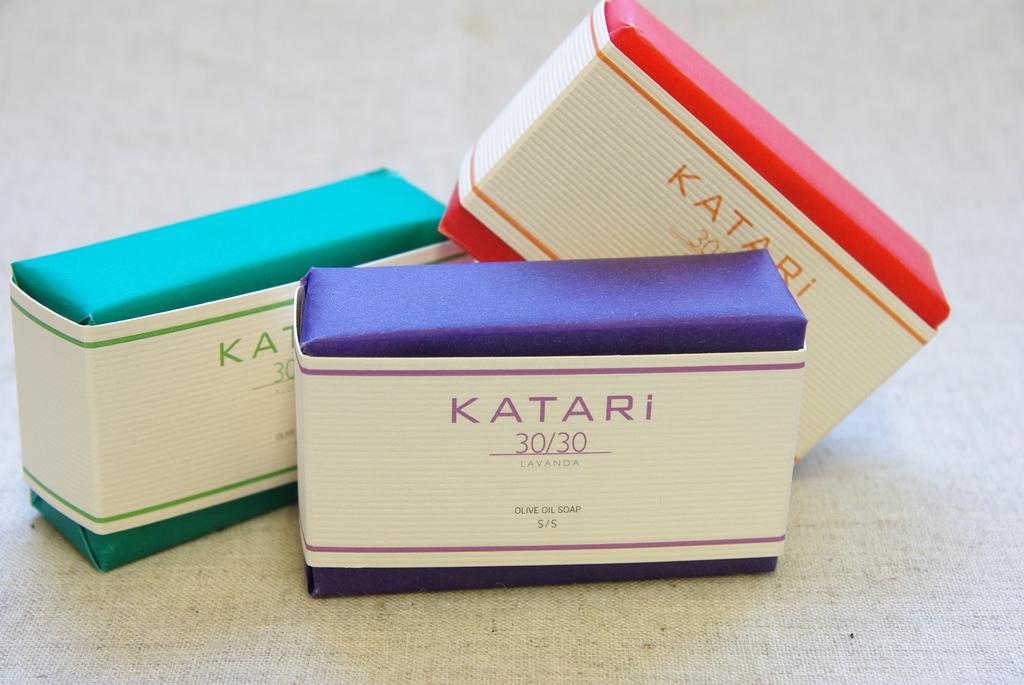What brand of soap is this?
Make the answer very short. Katari. What are the numbers on the front?
Ensure brevity in your answer.  30/30. 